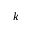Convert formula to latex. <formula><loc_0><loc_0><loc_500><loc_500>k</formula> 